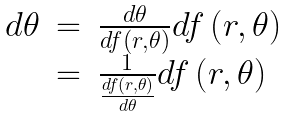Convert formula to latex. <formula><loc_0><loc_0><loc_500><loc_500>\begin{array} { r c l } d \theta & = & \frac { d \theta } { d f \left ( r , \theta \right ) } d f \left ( r , \theta \right ) \\ & = & \frac { 1 } { \frac { d f \left ( r , \theta \right ) } { d \theta } } d f \left ( r , \theta \right ) \end{array}</formula> 